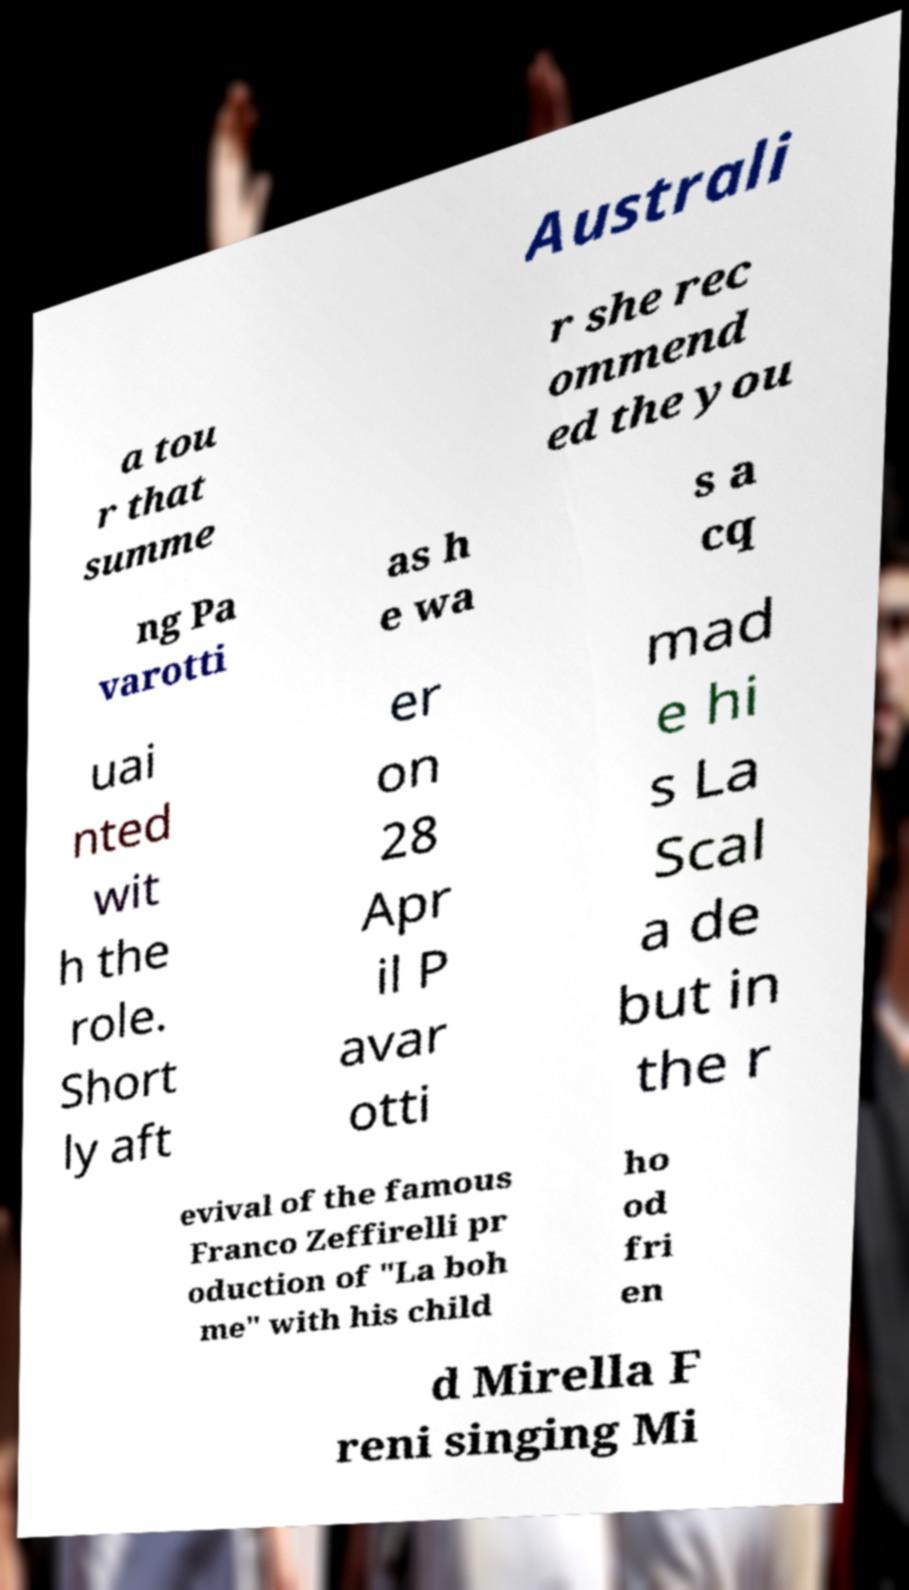For documentation purposes, I need the text within this image transcribed. Could you provide that? Australi a tou r that summe r she rec ommend ed the you ng Pa varotti as h e wa s a cq uai nted wit h the role. Short ly aft er on 28 Apr il P avar otti mad e hi s La Scal a de but in the r evival of the famous Franco Zeffirelli pr oduction of "La boh me" with his child ho od fri en d Mirella F reni singing Mi 